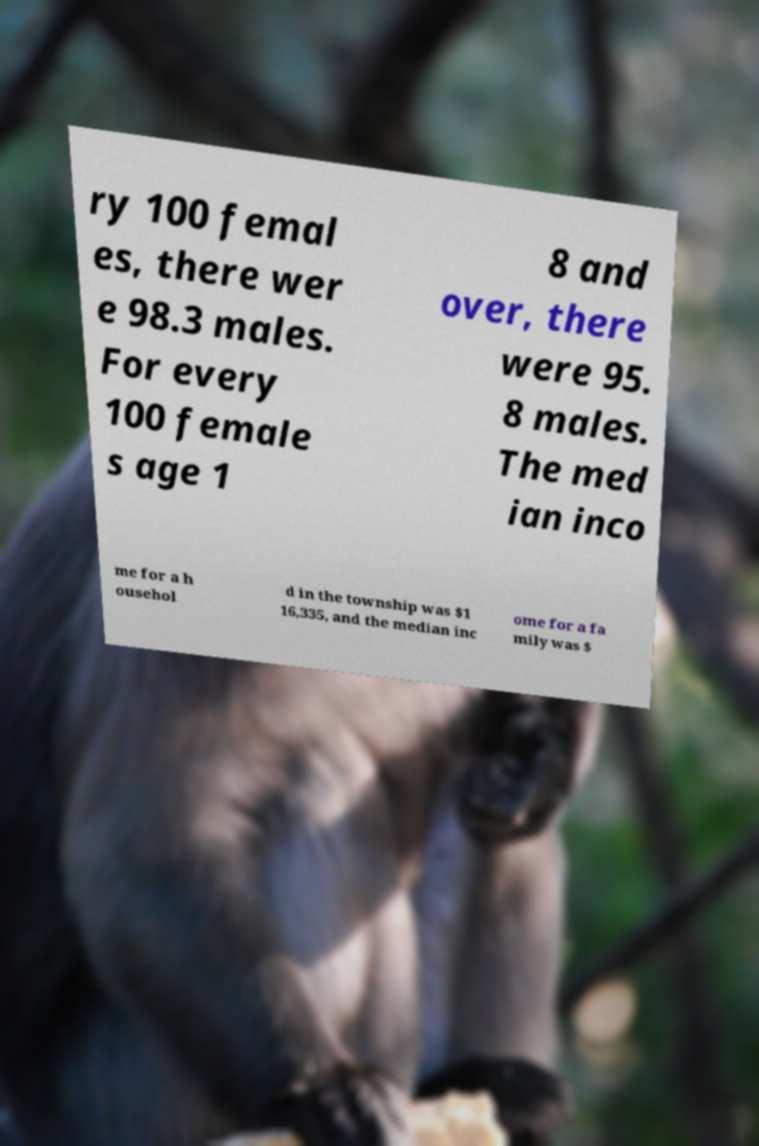For documentation purposes, I need the text within this image transcribed. Could you provide that? ry 100 femal es, there wer e 98.3 males. For every 100 female s age 1 8 and over, there were 95. 8 males. The med ian inco me for a h ousehol d in the township was $1 16,335, and the median inc ome for a fa mily was $ 